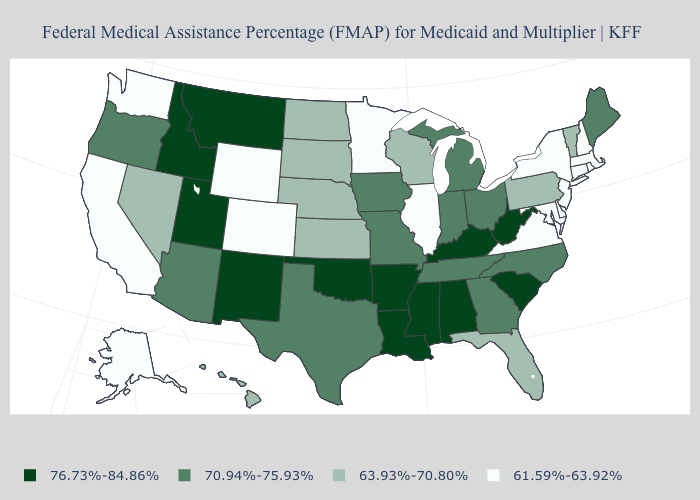Does the first symbol in the legend represent the smallest category?
Give a very brief answer. No. What is the highest value in the USA?
Be succinct. 76.73%-84.86%. Does Utah have the lowest value in the West?
Be succinct. No. What is the value of North Dakota?
Write a very short answer. 63.93%-70.80%. What is the value of Missouri?
Write a very short answer. 70.94%-75.93%. What is the value of North Carolina?
Give a very brief answer. 70.94%-75.93%. Name the states that have a value in the range 70.94%-75.93%?
Keep it brief. Arizona, Georgia, Indiana, Iowa, Maine, Michigan, Missouri, North Carolina, Ohio, Oregon, Tennessee, Texas. Among the states that border Florida , does Alabama have the lowest value?
Be succinct. No. What is the highest value in the West ?
Concise answer only. 76.73%-84.86%. Among the states that border Ohio , which have the highest value?
Keep it brief. Kentucky, West Virginia. Does the map have missing data?
Short answer required. No. What is the value of West Virginia?
Write a very short answer. 76.73%-84.86%. What is the value of Nevada?
Give a very brief answer. 63.93%-70.80%. Name the states that have a value in the range 63.93%-70.80%?
Give a very brief answer. Florida, Hawaii, Kansas, Nebraska, Nevada, North Dakota, Pennsylvania, South Dakota, Vermont, Wisconsin. What is the value of Arizona?
Keep it brief. 70.94%-75.93%. 